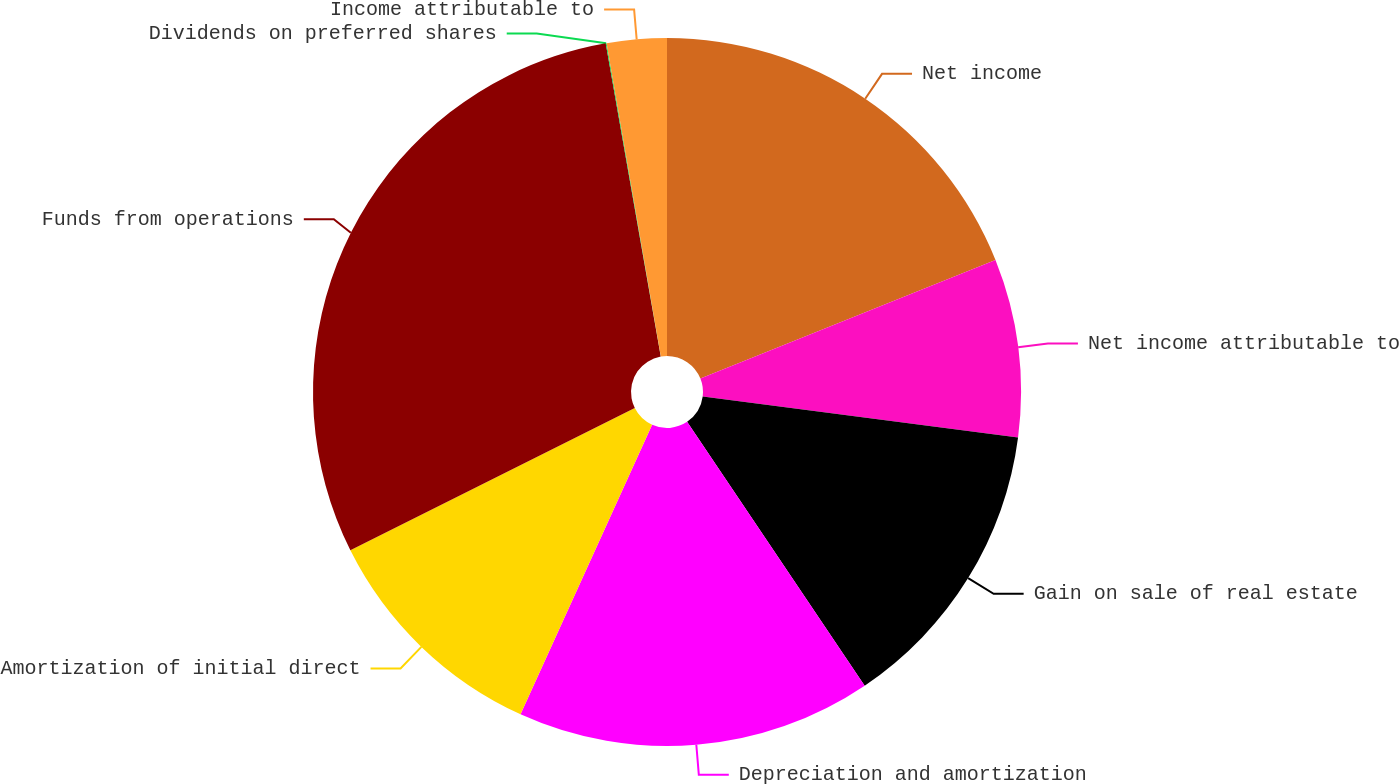<chart> <loc_0><loc_0><loc_500><loc_500><pie_chart><fcel>Net income<fcel>Net income attributable to<fcel>Gain on sale of real estate<fcel>Depreciation and amortization<fcel>Amortization of initial direct<fcel>Funds from operations<fcel>Dividends on preferred shares<fcel>Income attributable to<nl><fcel>18.92%<fcel>8.13%<fcel>13.52%<fcel>16.22%<fcel>10.83%<fcel>29.61%<fcel>0.04%<fcel>2.73%<nl></chart> 